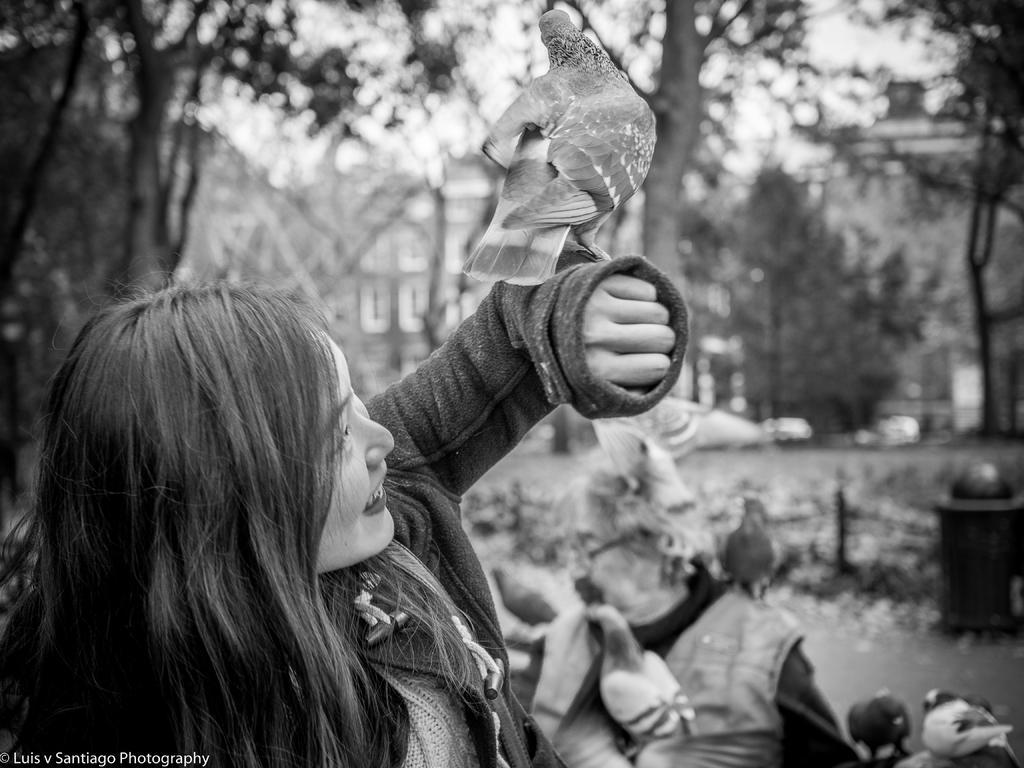In one or two sentences, can you explain what this image depicts? In this image I can see a person holding a bird. background I can see trees and sky, and the image is in black and white. 